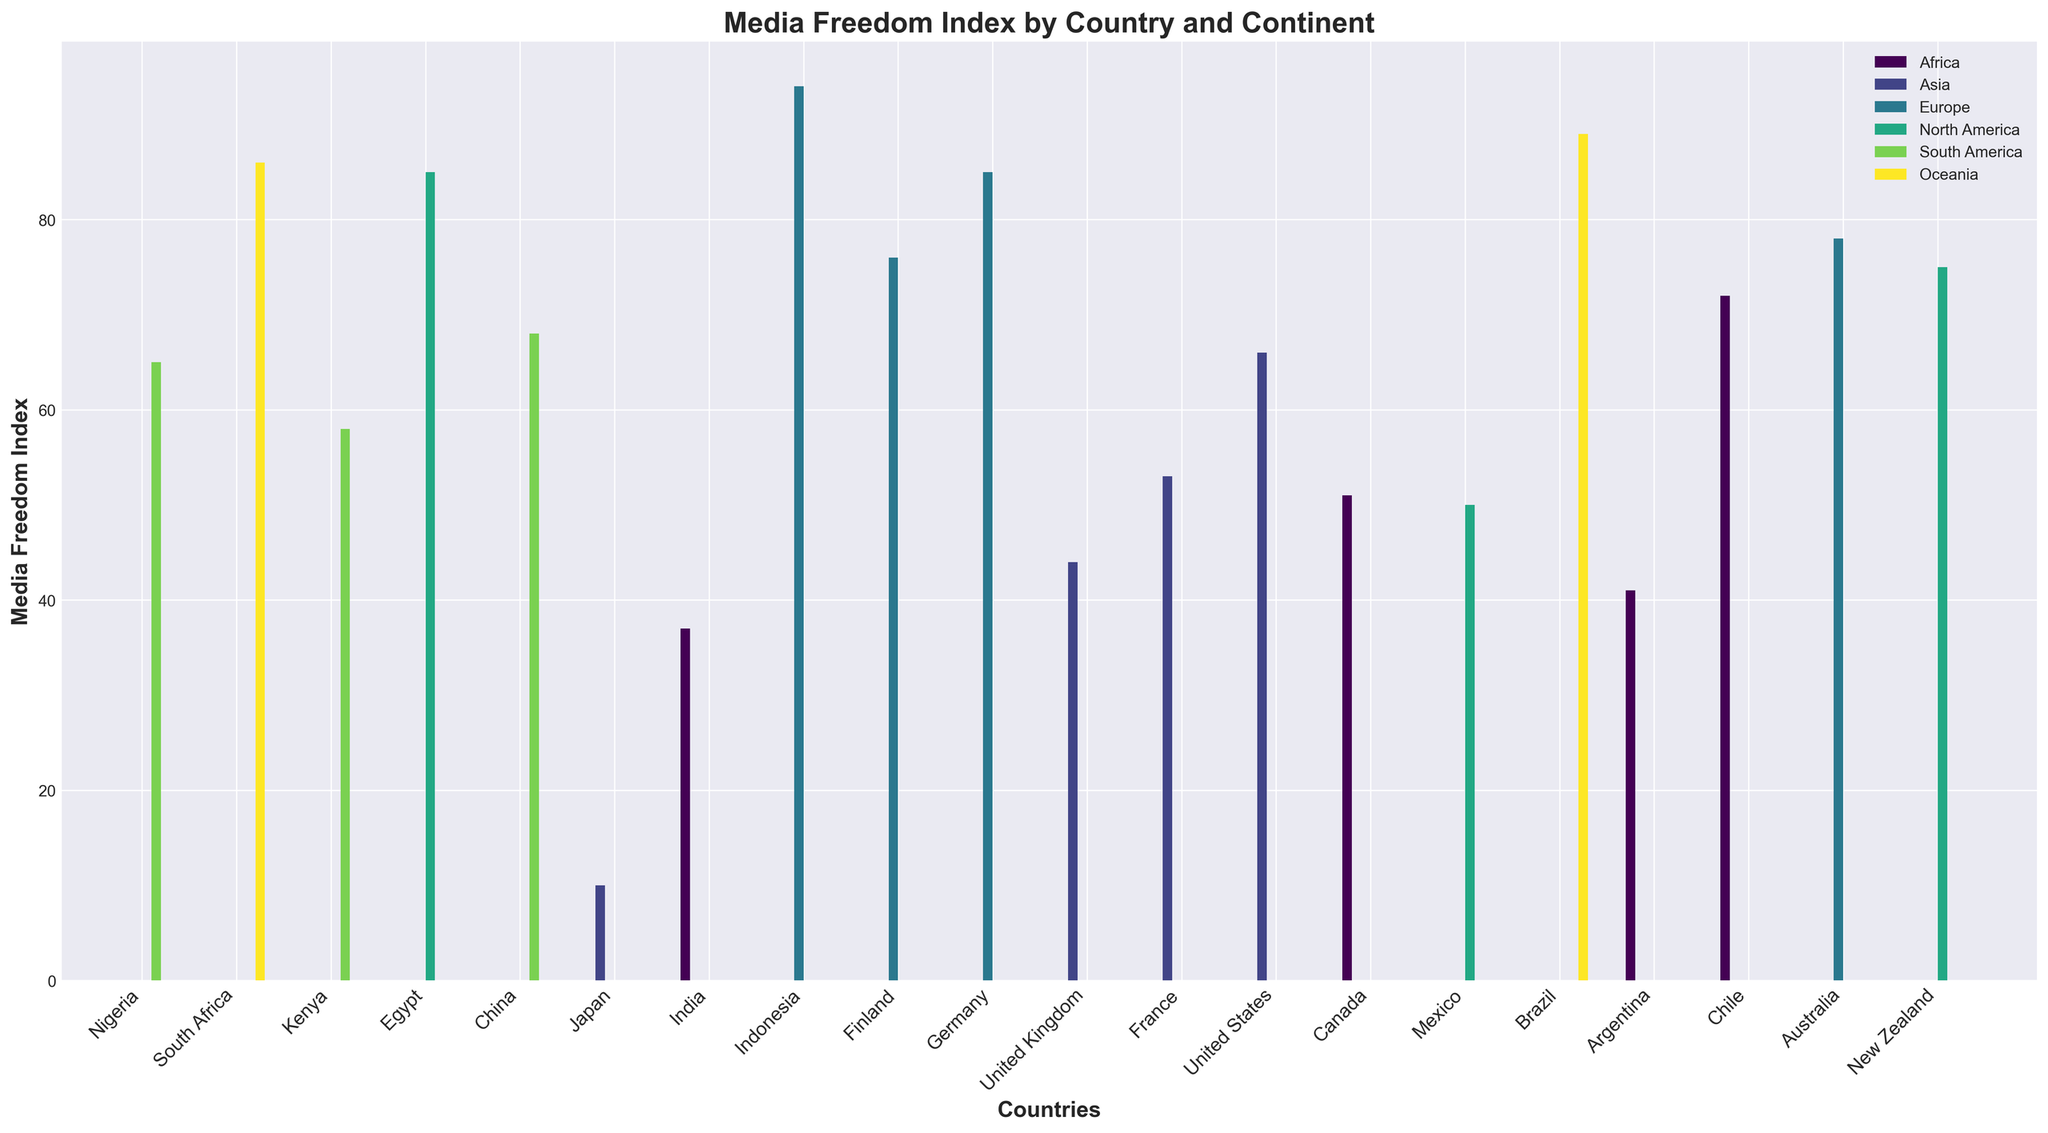Which continent has the country with the highest Media Freedom Index score? The highest Media Freedom Index score is 94, achieved by Finland. Finland is in Europe.
Answer: Europe What is the difference in Media Freedom Index between China and the United States? China has a score of 10 and the United States has a score of 75. The difference is calculated by subtracting 10 from 75.
Answer: 65 Which country in Africa has the highest Media Freedom Index score? The African countries listed are Nigeria, South Africa, Kenya, and Egypt. The scores are 41, 72, 51, and 37 respectively. The highest score among these is 72, which belongs to South Africa.
Answer: South Africa How many countries have a Media Freedom Index score above 80? The countries with scores above 80 are Finland (94), Germany (85), Canada (85), Australia (86), and New Zealand (89). Counting these gives us 5 countries.
Answer: 5 Which continent has the most countries listed with Media Freedom Index scores? The continents listed with their countries are Africa (4), Asia (4), Europe (4), North America (3), South America (3), and Oceania (2). Africa, Asia, and Europe each have 4 countries listed, which is the most.
Answer: Africa, Asia, and Europe Compare the Media Freedom Index of South America and North America by calculating the average score for each continent. Which one has a higher average score? South America: (58 + 65 + 68)/3 = 63.67, North America: (75 + 85 + 50)/3 = 70. The average score for North America is higher.
Answer: North America What is the median Media Freedom Index score for the countries listed in Asia? The scores for the Asian countries are 10 (China), 66 (Japan), 44 (India), 53 (Indonesia). Arranged in order: 10, 44, 53, 66. The median score is the average of 44 and 53, i.e., (44 + 53) / 2 = 48.5.
Answer: 48.5 Which country has the lowest Media Freedom Index score and which continent is it on? The lowest score is 10, which belongs to China. China is in Asia.
Answer: China, Asia What is the total sum of the Media Freedom Index scores for the countries in Europe? The scores for European countries are 94 (Finland), 85 (Germany), 78 (United Kingdom), and 76 (France). Summing these gives 94 + 85 + 78 + 76 = 333.
Answer: 333 Among the countries listed, which country in Oceania has the higher Media Freedom Index score and by how much? The countries in Oceania listed are Australia (86) and New Zealand (89). New Zealand has a higher score than Australia by 89 - 86 = 3.
Answer: New Zealand, 3 